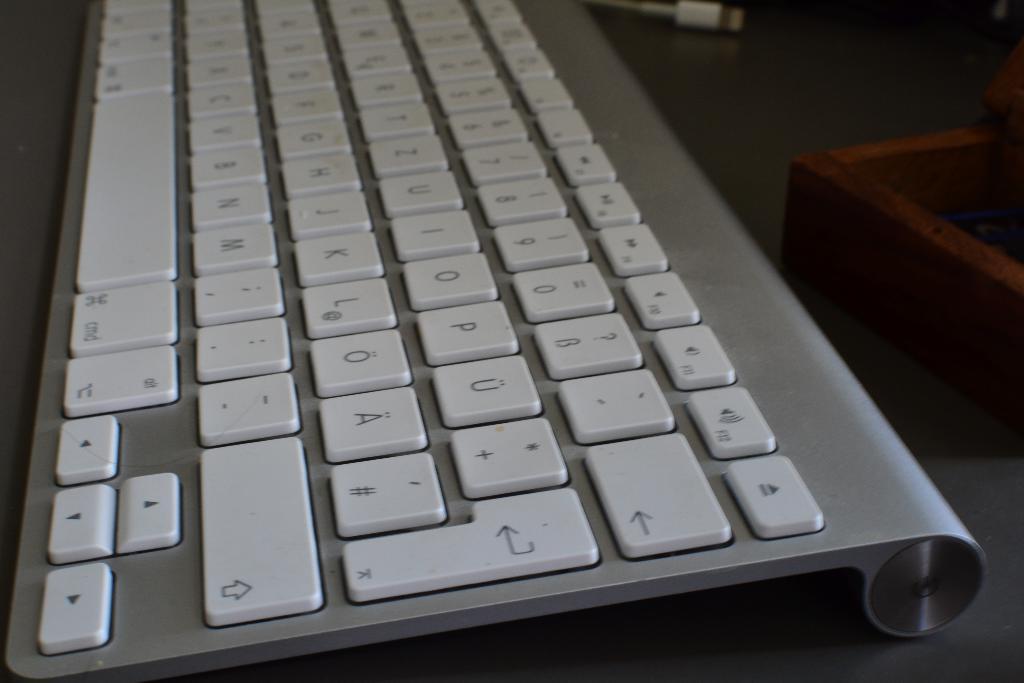Is this a keyboard?
Your answer should be very brief. Yes. 